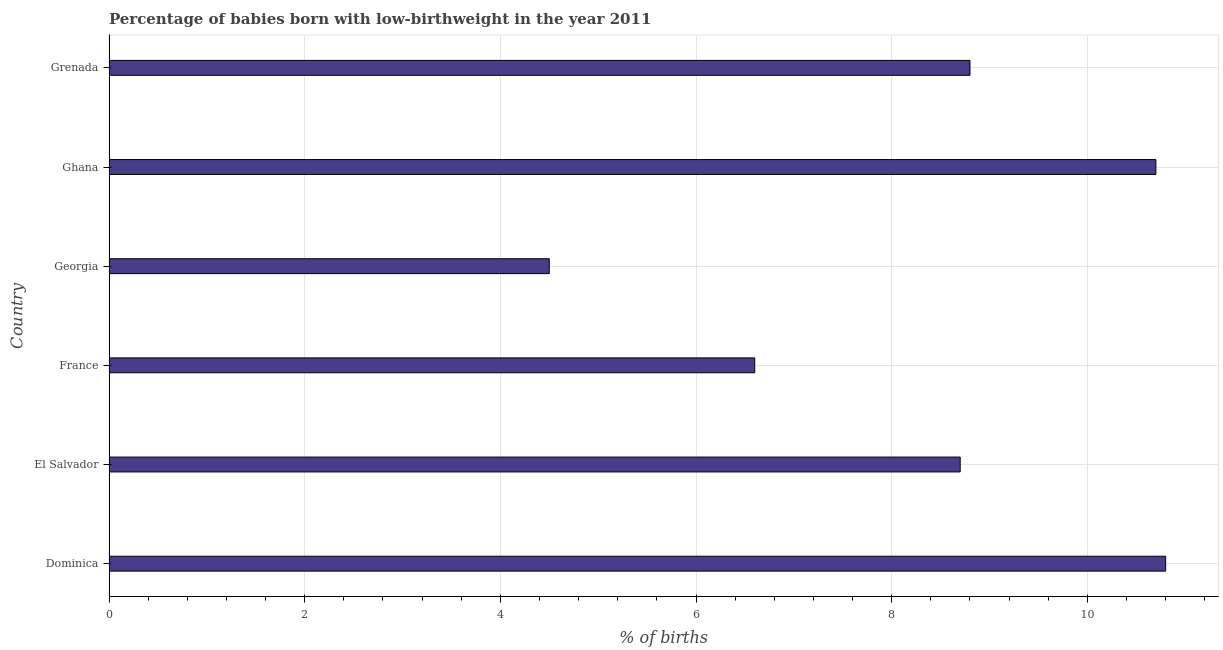Does the graph contain any zero values?
Your answer should be very brief. No. Does the graph contain grids?
Your answer should be compact. Yes. What is the title of the graph?
Offer a very short reply. Percentage of babies born with low-birthweight in the year 2011. What is the label or title of the X-axis?
Give a very brief answer. % of births. What is the label or title of the Y-axis?
Offer a terse response. Country. Across all countries, what is the maximum percentage of babies who were born with low-birthweight?
Keep it short and to the point. 10.8. In which country was the percentage of babies who were born with low-birthweight maximum?
Offer a terse response. Dominica. In which country was the percentage of babies who were born with low-birthweight minimum?
Your answer should be very brief. Georgia. What is the sum of the percentage of babies who were born with low-birthweight?
Your answer should be compact. 50.1. What is the average percentage of babies who were born with low-birthweight per country?
Give a very brief answer. 8.35. What is the median percentage of babies who were born with low-birthweight?
Ensure brevity in your answer.  8.75. What is the ratio of the percentage of babies who were born with low-birthweight in France to that in Georgia?
Ensure brevity in your answer.  1.47. Is the percentage of babies who were born with low-birthweight in Georgia less than that in Grenada?
Keep it short and to the point. Yes. Is the difference between the percentage of babies who were born with low-birthweight in El Salvador and Ghana greater than the difference between any two countries?
Your response must be concise. No. Is the sum of the percentage of babies who were born with low-birthweight in Ghana and Grenada greater than the maximum percentage of babies who were born with low-birthweight across all countries?
Offer a terse response. Yes. How many bars are there?
Provide a short and direct response. 6. Are all the bars in the graph horizontal?
Your answer should be very brief. Yes. How many countries are there in the graph?
Your response must be concise. 6. What is the difference between two consecutive major ticks on the X-axis?
Make the answer very short. 2. Are the values on the major ticks of X-axis written in scientific E-notation?
Give a very brief answer. No. What is the % of births in El Salvador?
Keep it short and to the point. 8.7. What is the % of births in France?
Keep it short and to the point. 6.6. What is the % of births in Georgia?
Give a very brief answer. 4.5. What is the % of births in Ghana?
Provide a succinct answer. 10.7. What is the % of births of Grenada?
Provide a succinct answer. 8.8. What is the difference between the % of births in Dominica and France?
Ensure brevity in your answer.  4.2. What is the difference between the % of births in Dominica and Grenada?
Offer a terse response. 2. What is the difference between the % of births in El Salvador and France?
Offer a terse response. 2.1. What is the difference between the % of births in El Salvador and Georgia?
Provide a succinct answer. 4.2. What is the difference between the % of births in El Salvador and Ghana?
Offer a very short reply. -2. What is the difference between the % of births in El Salvador and Grenada?
Provide a short and direct response. -0.1. What is the difference between the % of births in France and Georgia?
Give a very brief answer. 2.1. What is the difference between the % of births in France and Ghana?
Provide a succinct answer. -4.1. What is the difference between the % of births in Georgia and Grenada?
Your response must be concise. -4.3. What is the ratio of the % of births in Dominica to that in El Salvador?
Provide a succinct answer. 1.24. What is the ratio of the % of births in Dominica to that in France?
Your response must be concise. 1.64. What is the ratio of the % of births in Dominica to that in Georgia?
Give a very brief answer. 2.4. What is the ratio of the % of births in Dominica to that in Grenada?
Your answer should be compact. 1.23. What is the ratio of the % of births in El Salvador to that in France?
Keep it short and to the point. 1.32. What is the ratio of the % of births in El Salvador to that in Georgia?
Provide a succinct answer. 1.93. What is the ratio of the % of births in El Salvador to that in Ghana?
Make the answer very short. 0.81. What is the ratio of the % of births in France to that in Georgia?
Give a very brief answer. 1.47. What is the ratio of the % of births in France to that in Ghana?
Provide a succinct answer. 0.62. What is the ratio of the % of births in Georgia to that in Ghana?
Your answer should be compact. 0.42. What is the ratio of the % of births in Georgia to that in Grenada?
Ensure brevity in your answer.  0.51. What is the ratio of the % of births in Ghana to that in Grenada?
Your answer should be compact. 1.22. 